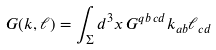Convert formula to latex. <formula><loc_0><loc_0><loc_500><loc_500>\ G ( k , \ell ) = \int _ { \Sigma } d ^ { 3 } x \, G ^ { q b \, c d } k _ { a b } \ell _ { c d } \,</formula> 